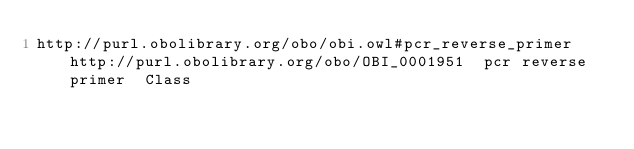Convert code to text. <code><loc_0><loc_0><loc_500><loc_500><_SQL_>http://purl.obolibrary.org/obo/obi.owl#pcr_reverse_primer	http://purl.obolibrary.org/obo/OBI_0001951	pcr reverse primer	Class
</code> 